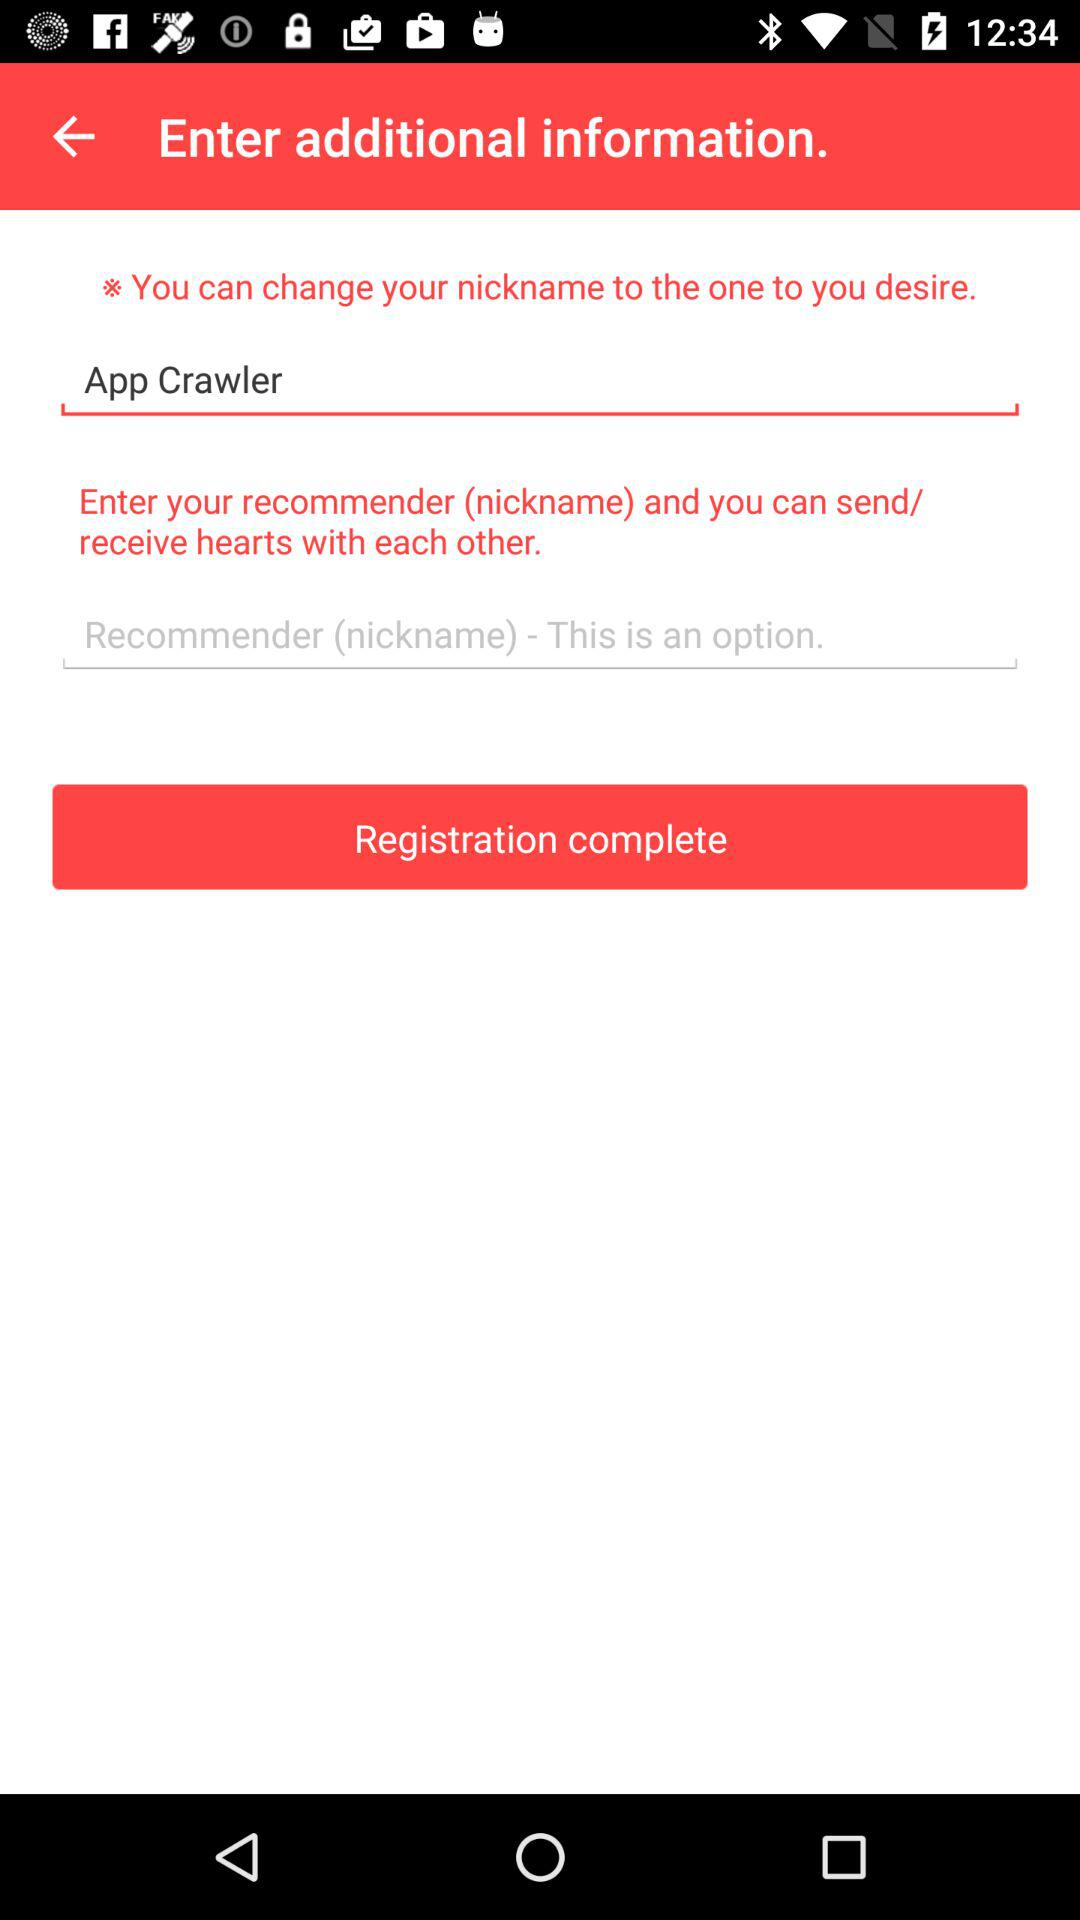Who is the recommender?
When the provided information is insufficient, respond with <no answer>. <no answer> 